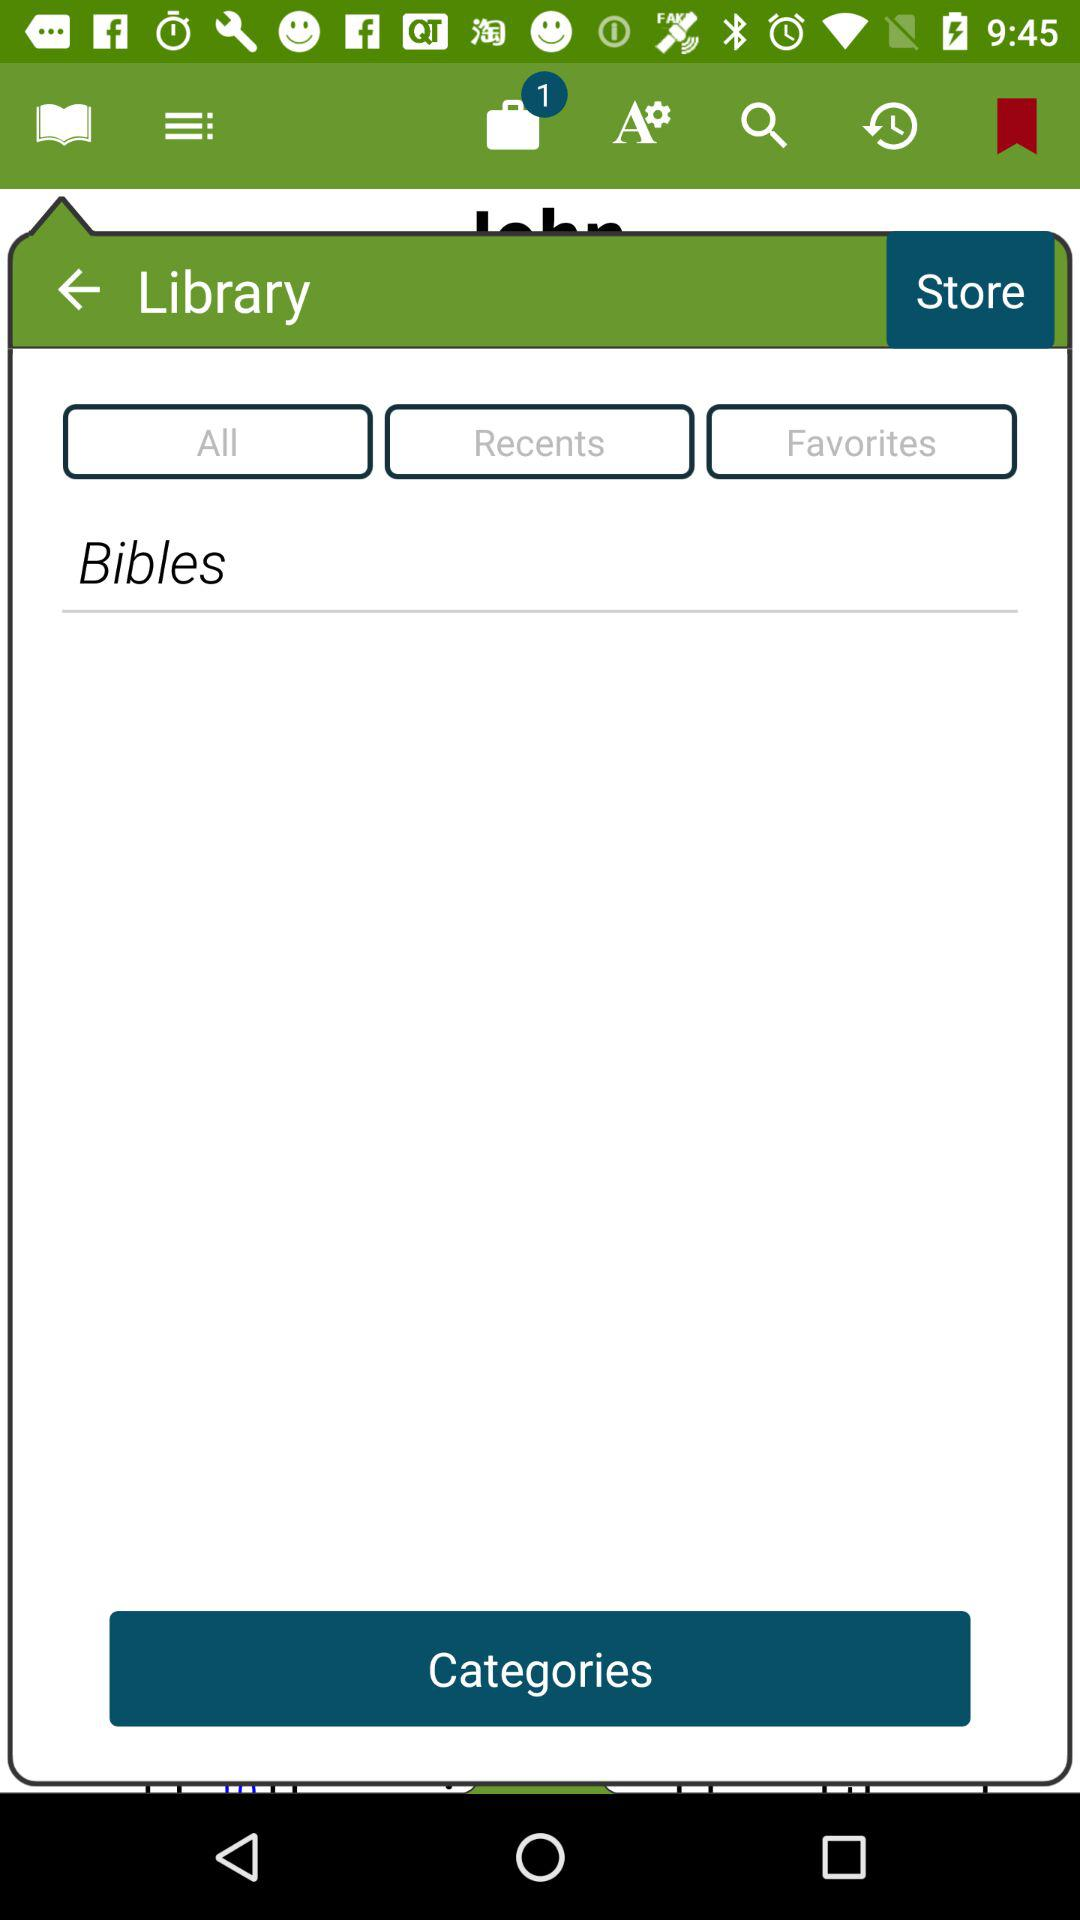How many items are there? There is 1 item. 